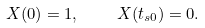<formula> <loc_0><loc_0><loc_500><loc_500>X ( 0 ) = 1 , \quad X ( t _ { s 0 } ) = 0 .</formula> 